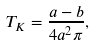Convert formula to latex. <formula><loc_0><loc_0><loc_500><loc_500>T _ { K } = \frac { a - b } { 4 a ^ { 2 } \pi } ,</formula> 